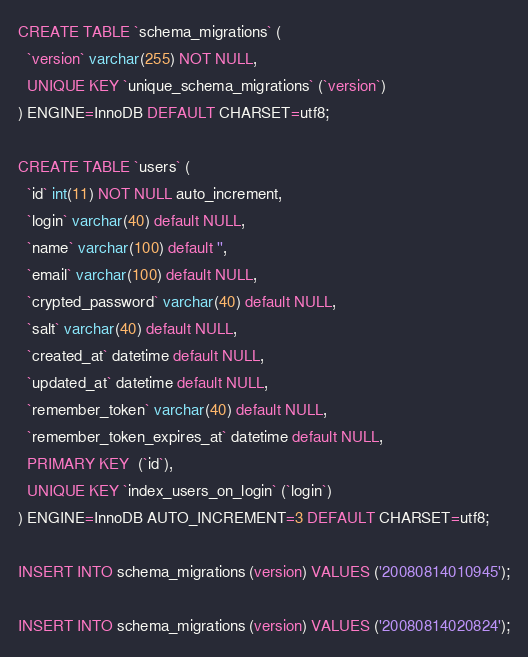Convert code to text. <code><loc_0><loc_0><loc_500><loc_500><_SQL_>
CREATE TABLE `schema_migrations` (
  `version` varchar(255) NOT NULL,
  UNIQUE KEY `unique_schema_migrations` (`version`)
) ENGINE=InnoDB DEFAULT CHARSET=utf8;

CREATE TABLE `users` (
  `id` int(11) NOT NULL auto_increment,
  `login` varchar(40) default NULL,
  `name` varchar(100) default '',
  `email` varchar(100) default NULL,
  `crypted_password` varchar(40) default NULL,
  `salt` varchar(40) default NULL,
  `created_at` datetime default NULL,
  `updated_at` datetime default NULL,
  `remember_token` varchar(40) default NULL,
  `remember_token_expires_at` datetime default NULL,
  PRIMARY KEY  (`id`),
  UNIQUE KEY `index_users_on_login` (`login`)
) ENGINE=InnoDB AUTO_INCREMENT=3 DEFAULT CHARSET=utf8;

INSERT INTO schema_migrations (version) VALUES ('20080814010945');

INSERT INTO schema_migrations (version) VALUES ('20080814020824');</code> 